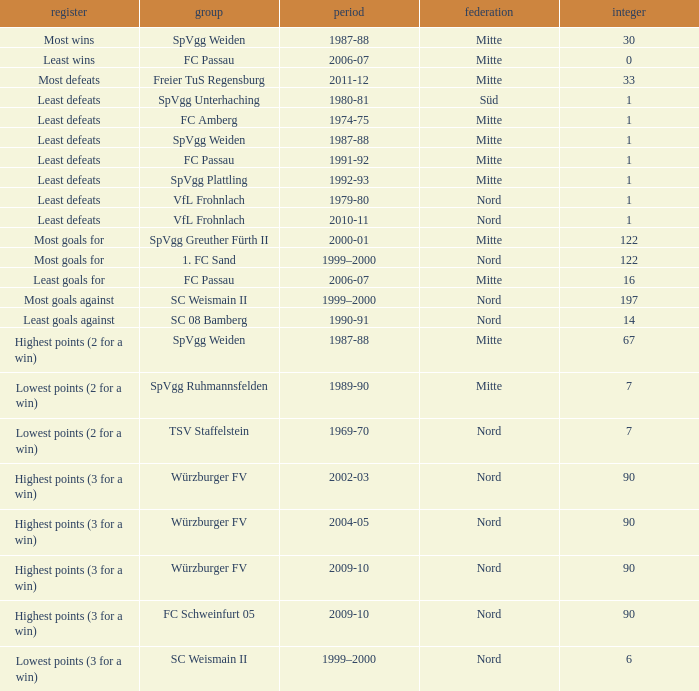What league has a number less than 1? Mitte. 